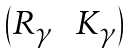<formula> <loc_0><loc_0><loc_500><loc_500>\begin{pmatrix} R _ { \gamma } & \, K _ { \gamma } \end{pmatrix}</formula> 